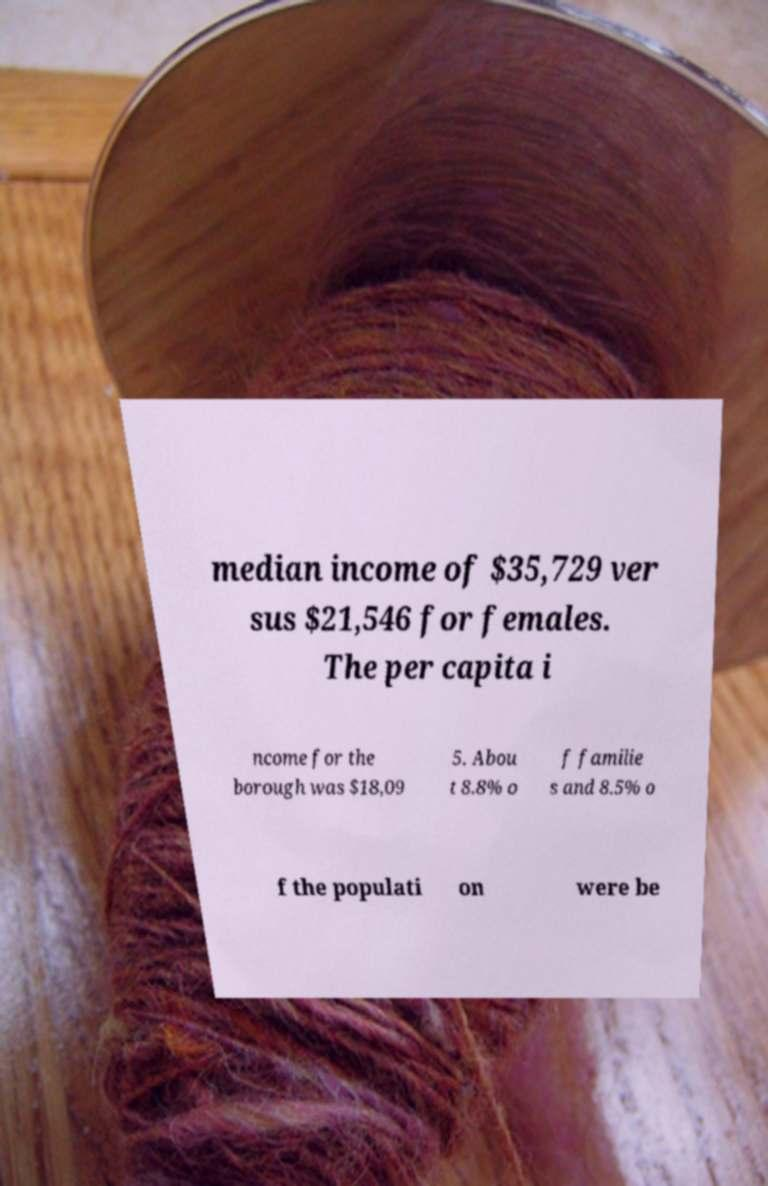Could you extract and type out the text from this image? median income of $35,729 ver sus $21,546 for females. The per capita i ncome for the borough was $18,09 5. Abou t 8.8% o f familie s and 8.5% o f the populati on were be 